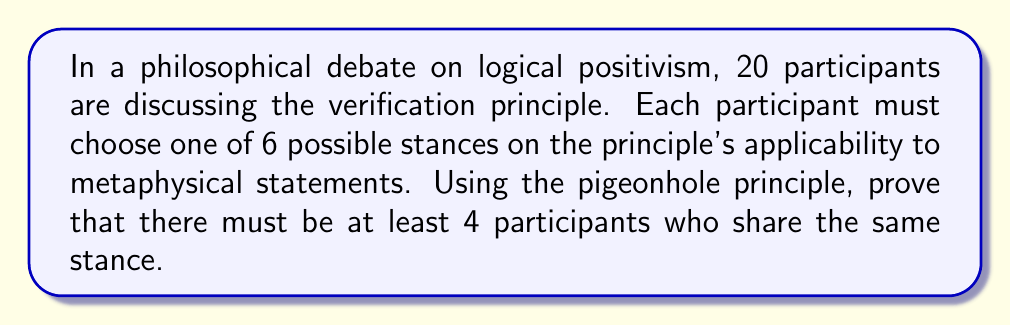Show me your answer to this math problem. Let's approach this problem step-by-step using the pigeonhole principle:

1. First, let's identify our pigeons and pigeonholes:
   - Pigeons: The 20 participants
   - Pigeonholes: The 6 possible stances on the verification principle

2. The pigeonhole principle states that if we have $n$ items to put into $m$ containers, and $n > m$, then at least one container must contain more than one item. More specifically, at least one container must contain at least $\lceil \frac{n}{m} \rceil$ items, where $\lceil x \rceil$ denotes the ceiling function.

3. In this case, we have:
   $n = 20$ (participants)
   $m = 6$ (stances)

4. Let's calculate $\lceil \frac{n}{m} \rceil$:
   $$\lceil \frac{20}{6} \rceil = \lceil 3.333... \rceil = 4$$

5. This means that at least one stance must be shared by at least 4 participants.

6. We can verify this by contradiction:
   - Assume the maximum number of participants sharing any stance is 3.
   - Then the maximum total number of participants would be $3 \times 6 = 18$.
   - But we know there are 20 participants, which contradicts our assumption.

7. Therefore, there must be at least 4 participants who share the same stance on the verification principle's applicability to metaphysical statements.

This application of the pigeonhole principle demonstrates how a seemingly complex philosophical scenario can be analyzed using discrete mathematical concepts, bridging the gap between philosophy of language and mathematical reasoning.
Answer: There must be at least 4 participants who share the same stance on the verification principle's applicability to metaphysical statements. 